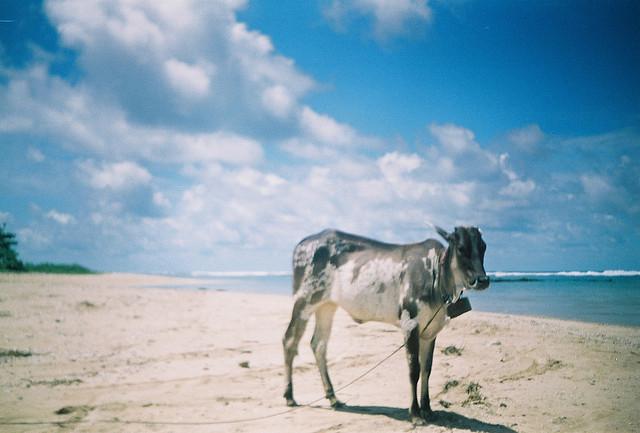What kind of animals are in this photo?
Be succinct. Cow. How many animals are there?
Give a very brief answer. 1. Is this cow healthy?
Keep it brief. No. Is it a cow or a bull?
Be succinct. Cow. Is the cow standing on grass?
Write a very short answer. No. How does the owner keep the cow from running off?
Concise answer only. Leash. 